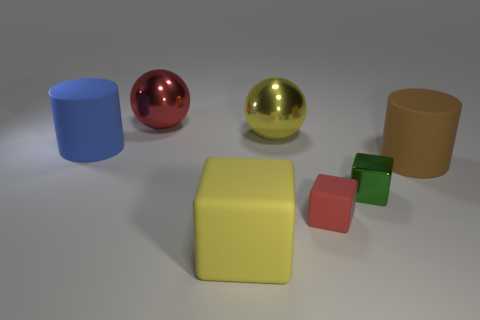Subtract all large cubes. How many cubes are left? 2 Add 1 yellow matte cylinders. How many objects exist? 8 Subtract all cylinders. How many objects are left? 5 Subtract all cyan cubes. Subtract all brown cylinders. How many cubes are left? 3 Subtract 0 gray blocks. How many objects are left? 7 Subtract all big metal balls. Subtract all small matte blocks. How many objects are left? 4 Add 7 brown cylinders. How many brown cylinders are left? 8 Add 2 green shiny cubes. How many green shiny cubes exist? 3 